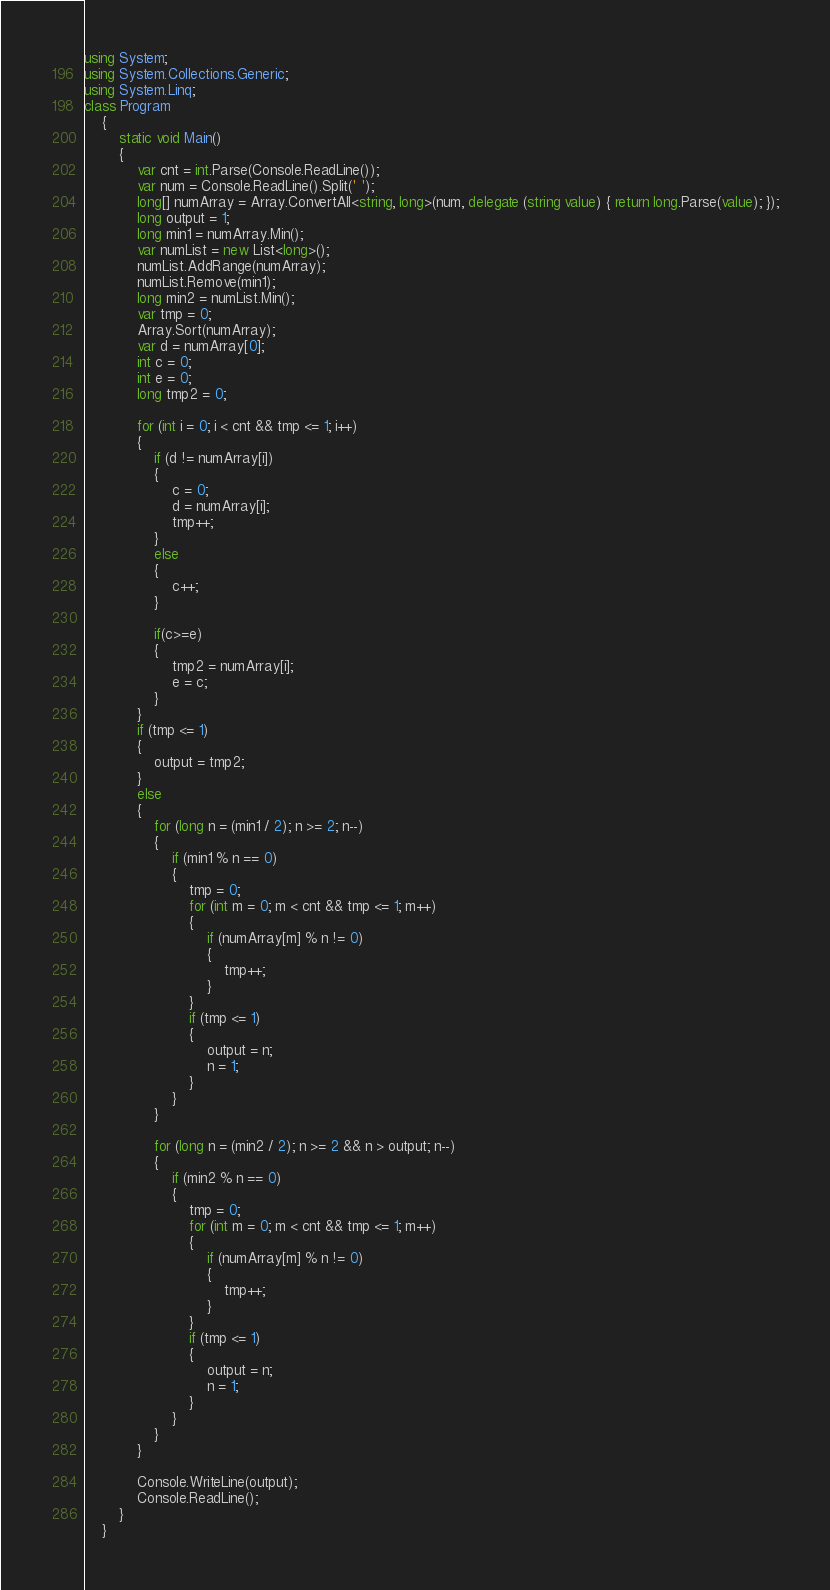Convert code to text. <code><loc_0><loc_0><loc_500><loc_500><_C#_>using System;
using System.Collections.Generic;
using System.Linq;
class Program
    {
        static void Main()
        {
            var cnt = int.Parse(Console.ReadLine());
            var num = Console.ReadLine().Split(' ');
            long[] numArray = Array.ConvertAll<string, long>(num, delegate (string value) { return long.Parse(value); });
            long output = 1;
            long min1 = numArray.Min();
            var numList = new List<long>();
            numList.AddRange(numArray);
            numList.Remove(min1);
            long min2 = numList.Min();
            var tmp = 0;
            Array.Sort(numArray);
            var d = numArray[0];
            int c = 0;
            int e = 0;
            long tmp2 = 0;

            for (int i = 0; i < cnt && tmp <= 1; i++)
            {
                if (d != numArray[i])
                {
                    c = 0;
                    d = numArray[i];
                    tmp++;
                }
                else
                {
                    c++;
                }

                if(c>=e)
                {
                    tmp2 = numArray[i];
                    e = c;
                }
            }
            if (tmp <= 1)
            {
                output = tmp2;
            }
            else
            {
                for (long n = (min1 / 2); n >= 2; n--)
                {
                    if (min1 % n == 0)
                    {
                        tmp = 0;
                        for (int m = 0; m < cnt && tmp <= 1; m++)
                        {
                            if (numArray[m] % n != 0)
                            {
                                tmp++;
                            }
                        }
                        if (tmp <= 1)
                        {
                            output = n;
                            n = 1;
                        }
                    }
                }

                for (long n = (min2 / 2); n >= 2 && n > output; n--)
                {
                    if (min2 % n == 0)
                    {
                        tmp = 0;
                        for (int m = 0; m < cnt && tmp <= 1; m++)
                        {
                            if (numArray[m] % n != 0)
                            {
                                tmp++;
                            }
                        }
                        if (tmp <= 1)
                        {
                            output = n;
                            n = 1;
                        }
                    }
                }
            }

            Console.WriteLine(output);
            Console.ReadLine();
        }
    }</code> 